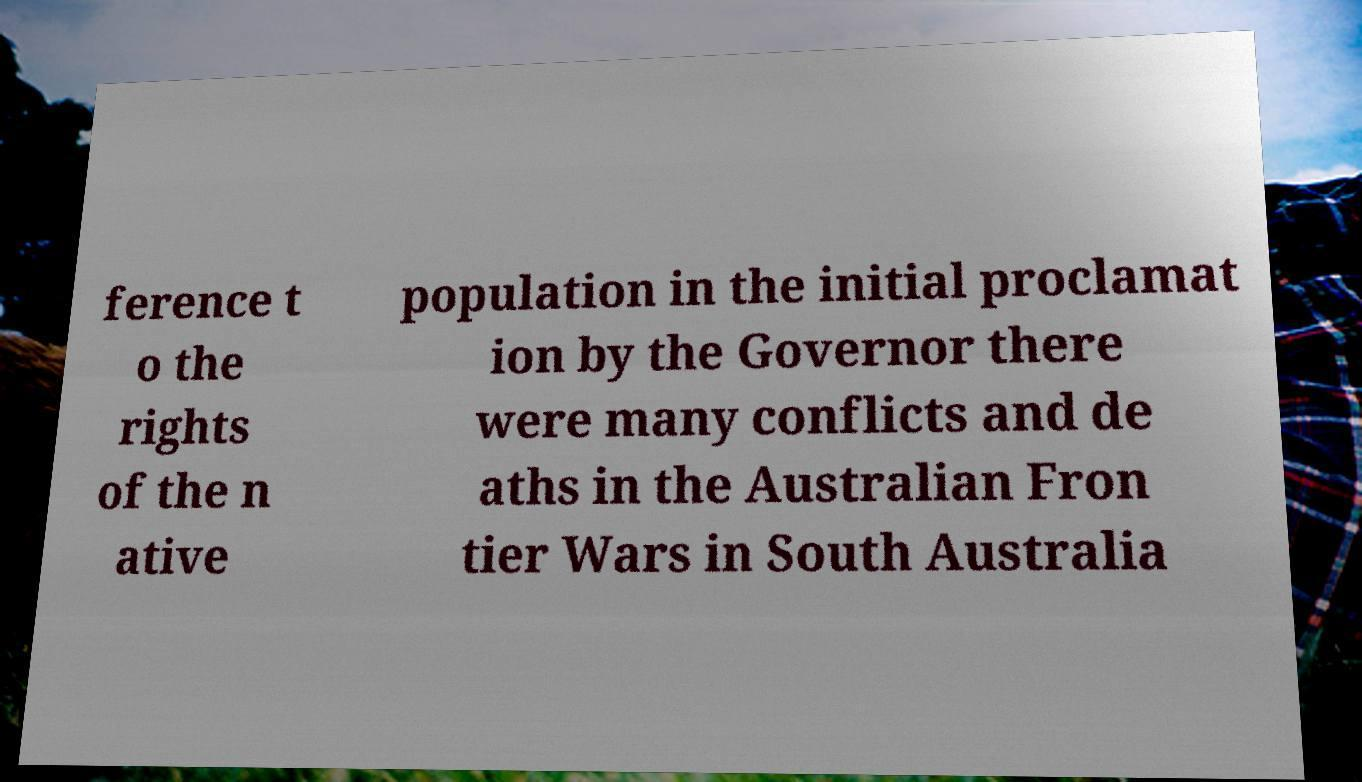What messages or text are displayed in this image? I need them in a readable, typed format. ference t o the rights of the n ative population in the initial proclamat ion by the Governor there were many conflicts and de aths in the Australian Fron tier Wars in South Australia 